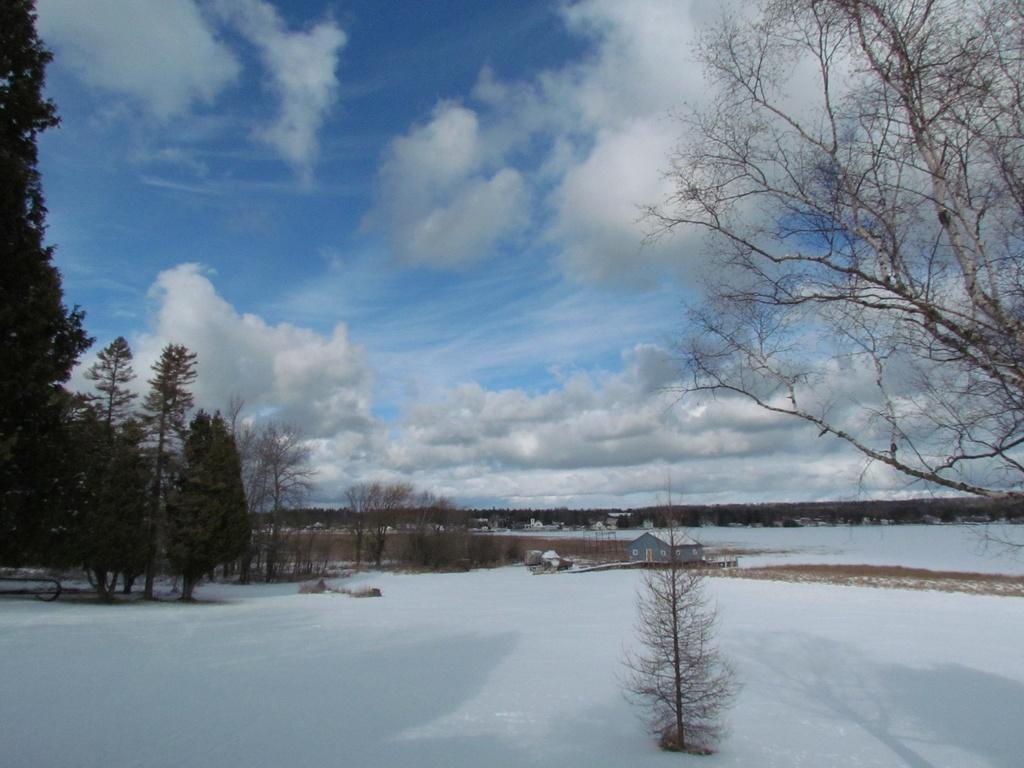How would you summarize this image in a sentence or two? We can see trees,snow and plant. A far we can see house and we can see sky with clouds. 